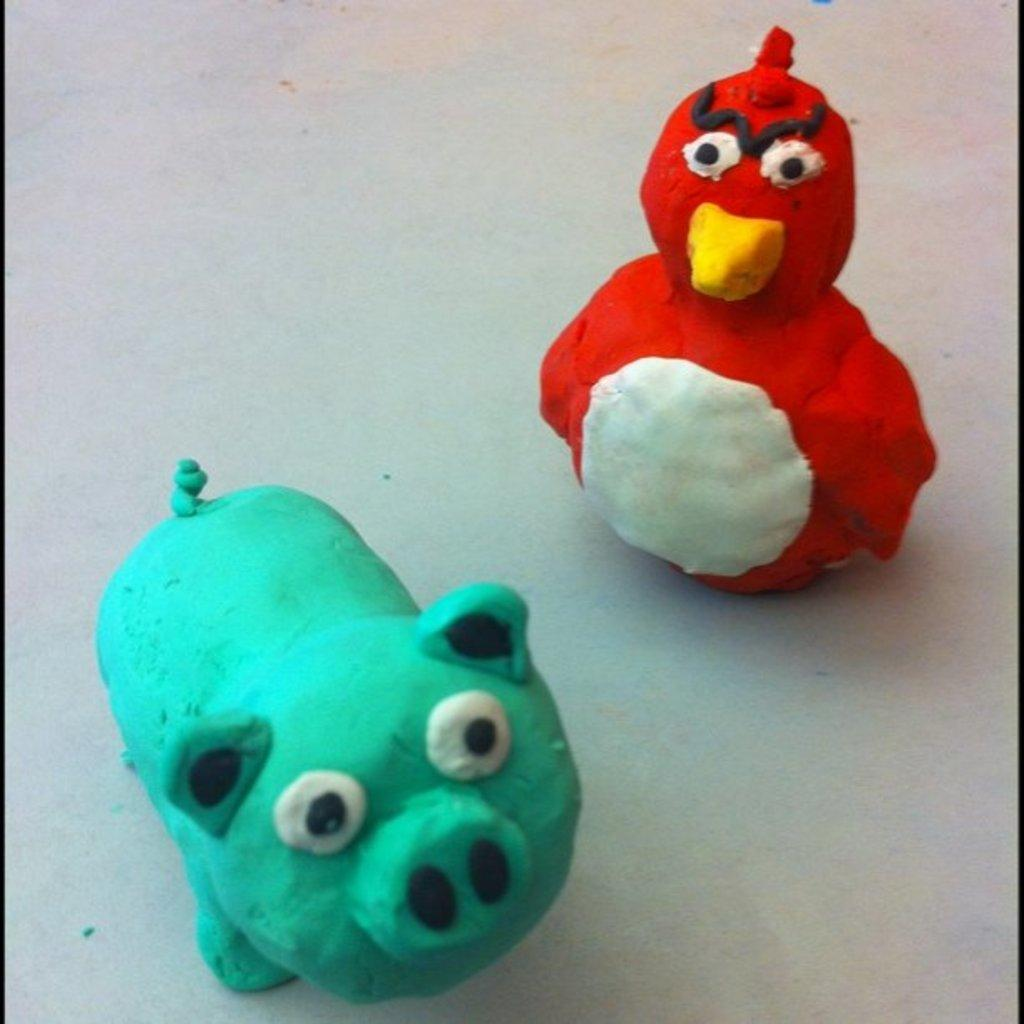What type of toys are featured in the image? There are toys made of clay in the image. What can be seen in the background of the image? The background of the image includes a floor. What type of trouble is the queen experiencing with the clay toys in the image? There is no queen or any indication of trouble in the image; it only features clay toys and a floor. 